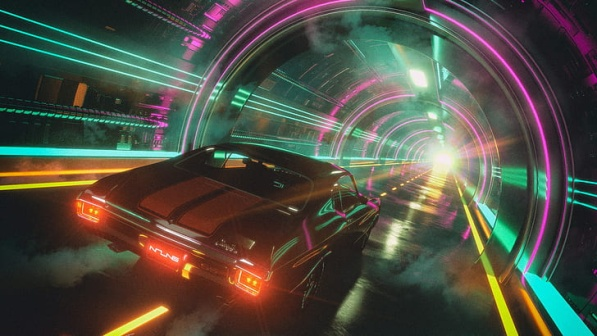What is this photo about? The image presents a visually stunning and futuristic scene, central to which is a sleek black sports car. This car, highlighted by its red taillights, is driving through a unique tunnel. Unlike ordinary tunnels, this one is designed with a series of arches illuminated by neon lights. These lights project vibrant colors that contrast with the otherwise dark surroundings, creating a mesmerizing visual effect. The car is moving towards a bright light at the end of the tunnel, suggesting its destination or exit. Overall, the scene conveys a dynamic sense of speed and forward momentum, symbolizing progress and a journey into the future. 